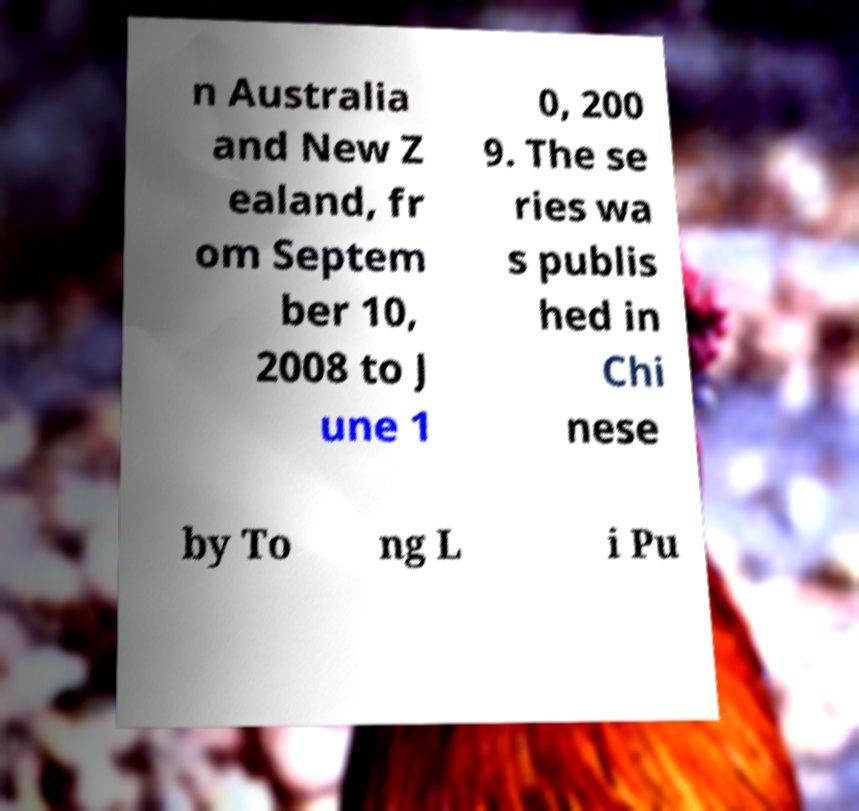Can you accurately transcribe the text from the provided image for me? n Australia and New Z ealand, fr om Septem ber 10, 2008 to J une 1 0, 200 9. The se ries wa s publis hed in Chi nese by To ng L i Pu 